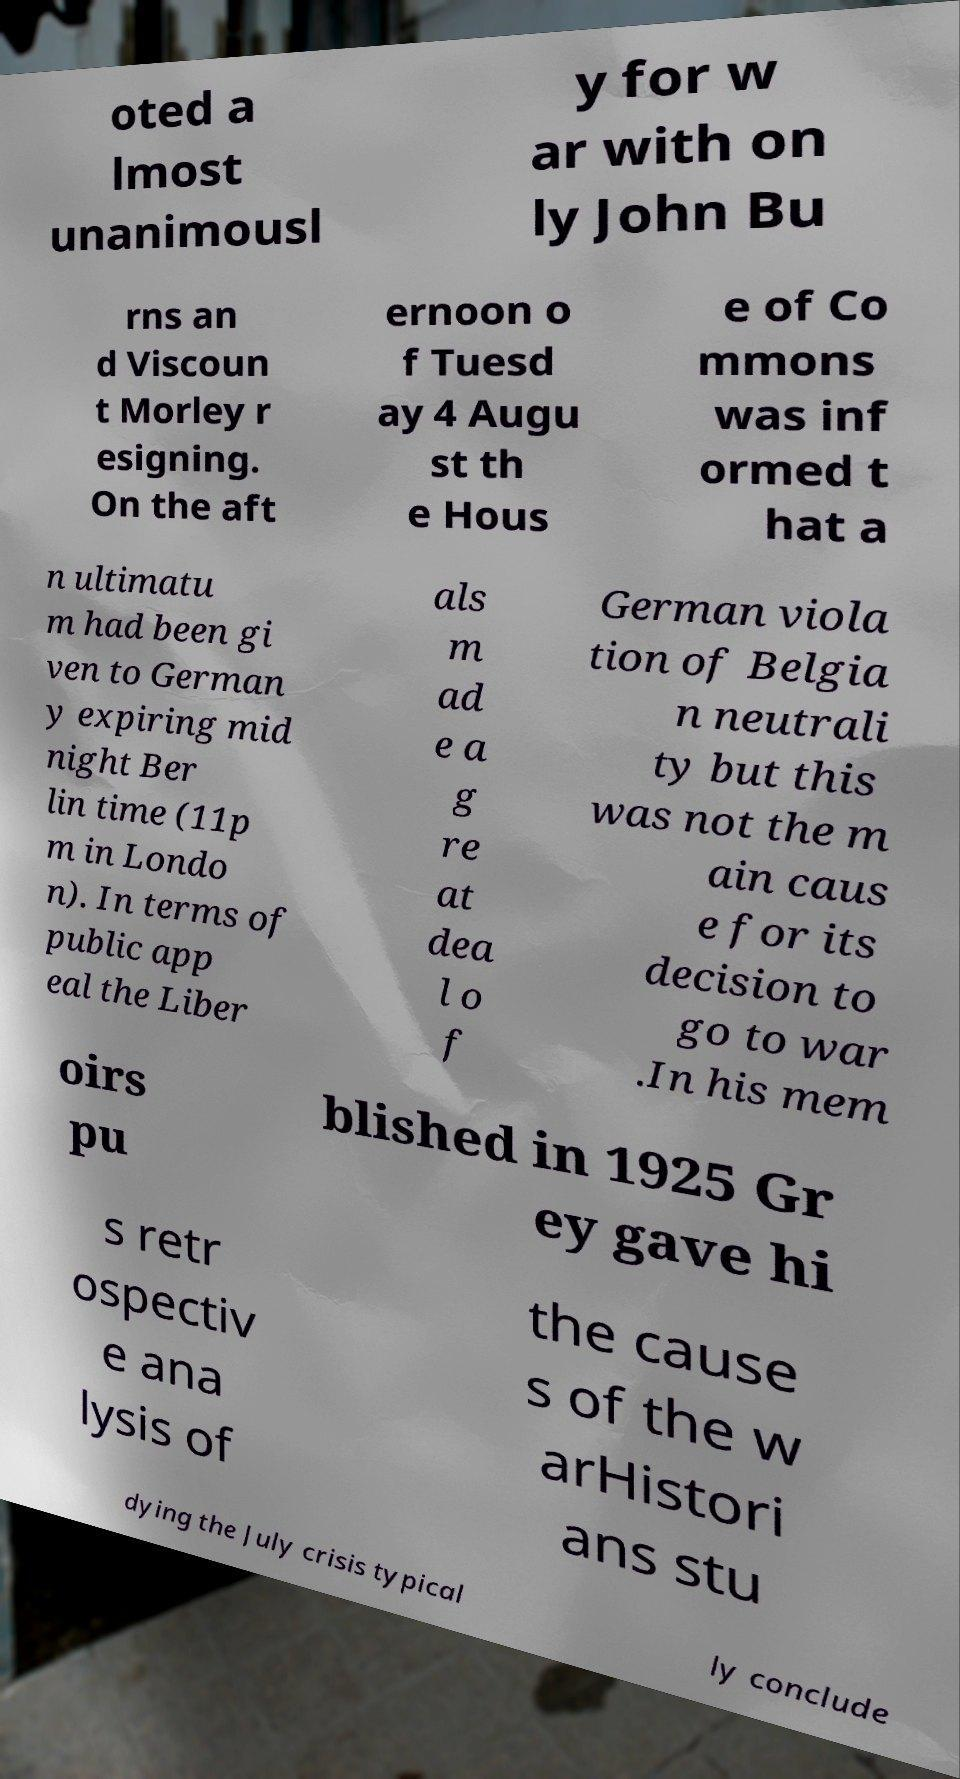Please identify and transcribe the text found in this image. oted a lmost unanimousl y for w ar with on ly John Bu rns an d Viscoun t Morley r esigning. On the aft ernoon o f Tuesd ay 4 Augu st th e Hous e of Co mmons was inf ormed t hat a n ultimatu m had been gi ven to German y expiring mid night Ber lin time (11p m in Londo n). In terms of public app eal the Liber als m ad e a g re at dea l o f German viola tion of Belgia n neutrali ty but this was not the m ain caus e for its decision to go to war .In his mem oirs pu blished in 1925 Gr ey gave hi s retr ospectiv e ana lysis of the cause s of the w arHistori ans stu dying the July crisis typical ly conclude 